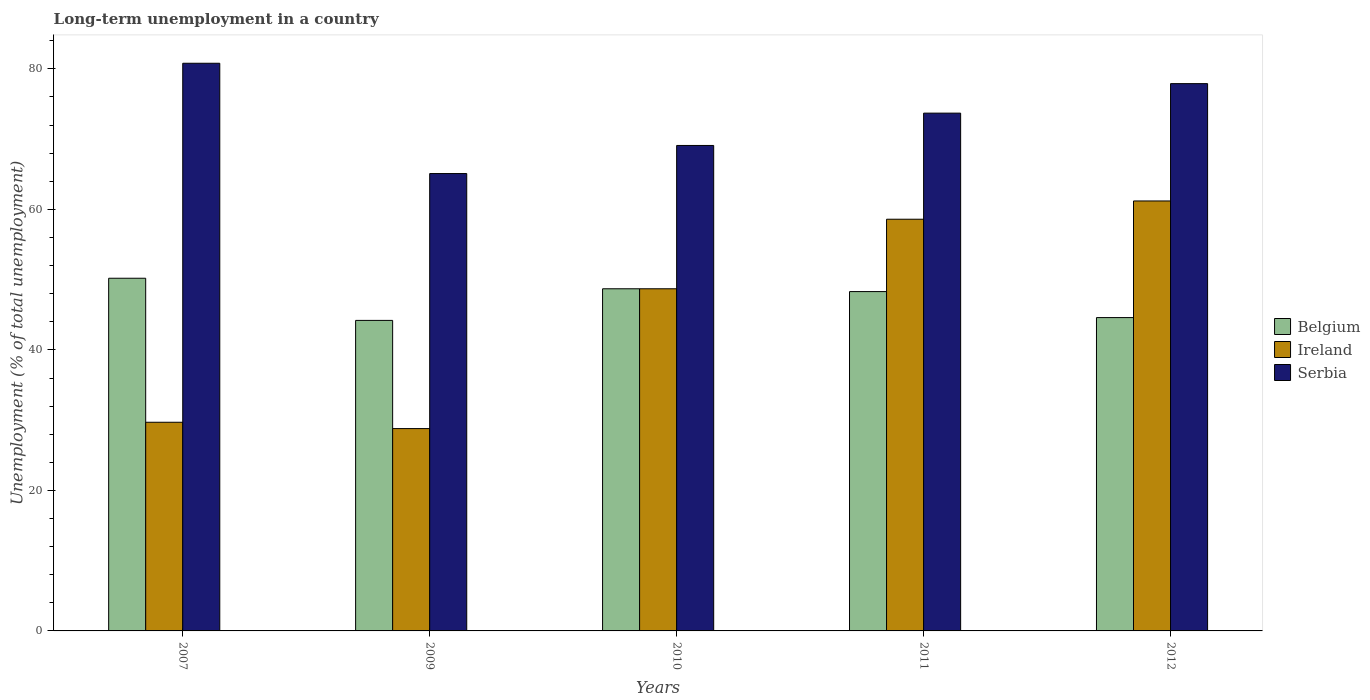How many different coloured bars are there?
Keep it short and to the point. 3. Are the number of bars per tick equal to the number of legend labels?
Offer a very short reply. Yes. Are the number of bars on each tick of the X-axis equal?
Your answer should be very brief. Yes. In how many cases, is the number of bars for a given year not equal to the number of legend labels?
Your answer should be compact. 0. What is the percentage of long-term unemployed population in Serbia in 2007?
Make the answer very short. 80.8. Across all years, what is the maximum percentage of long-term unemployed population in Ireland?
Ensure brevity in your answer.  61.2. Across all years, what is the minimum percentage of long-term unemployed population in Ireland?
Provide a short and direct response. 28.8. In which year was the percentage of long-term unemployed population in Belgium maximum?
Ensure brevity in your answer.  2007. In which year was the percentage of long-term unemployed population in Belgium minimum?
Ensure brevity in your answer.  2009. What is the total percentage of long-term unemployed population in Belgium in the graph?
Keep it short and to the point. 236. What is the difference between the percentage of long-term unemployed population in Serbia in 2007 and that in 2012?
Offer a terse response. 2.9. What is the difference between the percentage of long-term unemployed population in Ireland in 2010 and the percentage of long-term unemployed population in Serbia in 2012?
Ensure brevity in your answer.  -29.2. What is the average percentage of long-term unemployed population in Serbia per year?
Offer a terse response. 73.32. In the year 2007, what is the difference between the percentage of long-term unemployed population in Belgium and percentage of long-term unemployed population in Ireland?
Give a very brief answer. 20.5. What is the ratio of the percentage of long-term unemployed population in Belgium in 2010 to that in 2012?
Offer a very short reply. 1.09. What is the difference between the highest and the second highest percentage of long-term unemployed population in Ireland?
Keep it short and to the point. 2.6. What is the difference between the highest and the lowest percentage of long-term unemployed population in Serbia?
Keep it short and to the point. 15.7. What does the 3rd bar from the left in 2010 represents?
Keep it short and to the point. Serbia. What does the 3rd bar from the right in 2007 represents?
Keep it short and to the point. Belgium. Is it the case that in every year, the sum of the percentage of long-term unemployed population in Ireland and percentage of long-term unemployed population in Serbia is greater than the percentage of long-term unemployed population in Belgium?
Ensure brevity in your answer.  Yes. Are the values on the major ticks of Y-axis written in scientific E-notation?
Offer a very short reply. No. Does the graph contain any zero values?
Keep it short and to the point. No. Does the graph contain grids?
Provide a succinct answer. No. Where does the legend appear in the graph?
Offer a terse response. Center right. How many legend labels are there?
Your answer should be compact. 3. How are the legend labels stacked?
Ensure brevity in your answer.  Vertical. What is the title of the graph?
Provide a succinct answer. Long-term unemployment in a country. Does "French Polynesia" appear as one of the legend labels in the graph?
Provide a short and direct response. No. What is the label or title of the Y-axis?
Your response must be concise. Unemployment (% of total unemployment). What is the Unemployment (% of total unemployment) of Belgium in 2007?
Offer a very short reply. 50.2. What is the Unemployment (% of total unemployment) in Ireland in 2007?
Your answer should be compact. 29.7. What is the Unemployment (% of total unemployment) in Serbia in 2007?
Provide a short and direct response. 80.8. What is the Unemployment (% of total unemployment) in Belgium in 2009?
Offer a terse response. 44.2. What is the Unemployment (% of total unemployment) of Ireland in 2009?
Your answer should be compact. 28.8. What is the Unemployment (% of total unemployment) in Serbia in 2009?
Offer a very short reply. 65.1. What is the Unemployment (% of total unemployment) of Belgium in 2010?
Give a very brief answer. 48.7. What is the Unemployment (% of total unemployment) in Ireland in 2010?
Your answer should be very brief. 48.7. What is the Unemployment (% of total unemployment) of Serbia in 2010?
Ensure brevity in your answer.  69.1. What is the Unemployment (% of total unemployment) in Belgium in 2011?
Make the answer very short. 48.3. What is the Unemployment (% of total unemployment) of Ireland in 2011?
Your answer should be very brief. 58.6. What is the Unemployment (% of total unemployment) of Serbia in 2011?
Your response must be concise. 73.7. What is the Unemployment (% of total unemployment) of Belgium in 2012?
Your response must be concise. 44.6. What is the Unemployment (% of total unemployment) in Ireland in 2012?
Offer a very short reply. 61.2. What is the Unemployment (% of total unemployment) of Serbia in 2012?
Make the answer very short. 77.9. Across all years, what is the maximum Unemployment (% of total unemployment) of Belgium?
Provide a short and direct response. 50.2. Across all years, what is the maximum Unemployment (% of total unemployment) of Ireland?
Offer a terse response. 61.2. Across all years, what is the maximum Unemployment (% of total unemployment) of Serbia?
Keep it short and to the point. 80.8. Across all years, what is the minimum Unemployment (% of total unemployment) of Belgium?
Offer a very short reply. 44.2. Across all years, what is the minimum Unemployment (% of total unemployment) in Ireland?
Provide a succinct answer. 28.8. Across all years, what is the minimum Unemployment (% of total unemployment) in Serbia?
Make the answer very short. 65.1. What is the total Unemployment (% of total unemployment) of Belgium in the graph?
Your answer should be very brief. 236. What is the total Unemployment (% of total unemployment) of Ireland in the graph?
Give a very brief answer. 227. What is the total Unemployment (% of total unemployment) of Serbia in the graph?
Your response must be concise. 366.6. What is the difference between the Unemployment (% of total unemployment) of Belgium in 2007 and that in 2009?
Provide a short and direct response. 6. What is the difference between the Unemployment (% of total unemployment) in Serbia in 2007 and that in 2009?
Ensure brevity in your answer.  15.7. What is the difference between the Unemployment (% of total unemployment) in Ireland in 2007 and that in 2010?
Keep it short and to the point. -19. What is the difference between the Unemployment (% of total unemployment) in Serbia in 2007 and that in 2010?
Your answer should be compact. 11.7. What is the difference between the Unemployment (% of total unemployment) of Belgium in 2007 and that in 2011?
Offer a terse response. 1.9. What is the difference between the Unemployment (% of total unemployment) of Ireland in 2007 and that in 2011?
Your answer should be very brief. -28.9. What is the difference between the Unemployment (% of total unemployment) in Serbia in 2007 and that in 2011?
Provide a short and direct response. 7.1. What is the difference between the Unemployment (% of total unemployment) in Belgium in 2007 and that in 2012?
Provide a succinct answer. 5.6. What is the difference between the Unemployment (% of total unemployment) of Ireland in 2007 and that in 2012?
Your answer should be very brief. -31.5. What is the difference between the Unemployment (% of total unemployment) of Ireland in 2009 and that in 2010?
Ensure brevity in your answer.  -19.9. What is the difference between the Unemployment (% of total unemployment) in Belgium in 2009 and that in 2011?
Make the answer very short. -4.1. What is the difference between the Unemployment (% of total unemployment) of Ireland in 2009 and that in 2011?
Provide a short and direct response. -29.8. What is the difference between the Unemployment (% of total unemployment) in Serbia in 2009 and that in 2011?
Provide a succinct answer. -8.6. What is the difference between the Unemployment (% of total unemployment) of Belgium in 2009 and that in 2012?
Your answer should be very brief. -0.4. What is the difference between the Unemployment (% of total unemployment) of Ireland in 2009 and that in 2012?
Make the answer very short. -32.4. What is the difference between the Unemployment (% of total unemployment) of Serbia in 2009 and that in 2012?
Make the answer very short. -12.8. What is the difference between the Unemployment (% of total unemployment) of Belgium in 2010 and that in 2011?
Provide a short and direct response. 0.4. What is the difference between the Unemployment (% of total unemployment) of Ireland in 2010 and that in 2011?
Your answer should be very brief. -9.9. What is the difference between the Unemployment (% of total unemployment) in Serbia in 2010 and that in 2011?
Your response must be concise. -4.6. What is the difference between the Unemployment (% of total unemployment) of Serbia in 2010 and that in 2012?
Give a very brief answer. -8.8. What is the difference between the Unemployment (% of total unemployment) of Belgium in 2007 and the Unemployment (% of total unemployment) of Ireland in 2009?
Your response must be concise. 21.4. What is the difference between the Unemployment (% of total unemployment) of Belgium in 2007 and the Unemployment (% of total unemployment) of Serbia in 2009?
Your response must be concise. -14.9. What is the difference between the Unemployment (% of total unemployment) in Ireland in 2007 and the Unemployment (% of total unemployment) in Serbia in 2009?
Give a very brief answer. -35.4. What is the difference between the Unemployment (% of total unemployment) in Belgium in 2007 and the Unemployment (% of total unemployment) in Ireland in 2010?
Provide a short and direct response. 1.5. What is the difference between the Unemployment (% of total unemployment) in Belgium in 2007 and the Unemployment (% of total unemployment) in Serbia in 2010?
Give a very brief answer. -18.9. What is the difference between the Unemployment (% of total unemployment) in Ireland in 2007 and the Unemployment (% of total unemployment) in Serbia in 2010?
Your answer should be compact. -39.4. What is the difference between the Unemployment (% of total unemployment) of Belgium in 2007 and the Unemployment (% of total unemployment) of Ireland in 2011?
Offer a terse response. -8.4. What is the difference between the Unemployment (% of total unemployment) of Belgium in 2007 and the Unemployment (% of total unemployment) of Serbia in 2011?
Ensure brevity in your answer.  -23.5. What is the difference between the Unemployment (% of total unemployment) in Ireland in 2007 and the Unemployment (% of total unemployment) in Serbia in 2011?
Make the answer very short. -44. What is the difference between the Unemployment (% of total unemployment) in Belgium in 2007 and the Unemployment (% of total unemployment) in Ireland in 2012?
Provide a succinct answer. -11. What is the difference between the Unemployment (% of total unemployment) of Belgium in 2007 and the Unemployment (% of total unemployment) of Serbia in 2012?
Keep it short and to the point. -27.7. What is the difference between the Unemployment (% of total unemployment) of Ireland in 2007 and the Unemployment (% of total unemployment) of Serbia in 2012?
Provide a succinct answer. -48.2. What is the difference between the Unemployment (% of total unemployment) of Belgium in 2009 and the Unemployment (% of total unemployment) of Serbia in 2010?
Keep it short and to the point. -24.9. What is the difference between the Unemployment (% of total unemployment) in Ireland in 2009 and the Unemployment (% of total unemployment) in Serbia in 2010?
Offer a very short reply. -40.3. What is the difference between the Unemployment (% of total unemployment) of Belgium in 2009 and the Unemployment (% of total unemployment) of Ireland in 2011?
Offer a very short reply. -14.4. What is the difference between the Unemployment (% of total unemployment) in Belgium in 2009 and the Unemployment (% of total unemployment) in Serbia in 2011?
Your answer should be compact. -29.5. What is the difference between the Unemployment (% of total unemployment) of Ireland in 2009 and the Unemployment (% of total unemployment) of Serbia in 2011?
Your answer should be compact. -44.9. What is the difference between the Unemployment (% of total unemployment) of Belgium in 2009 and the Unemployment (% of total unemployment) of Ireland in 2012?
Provide a short and direct response. -17. What is the difference between the Unemployment (% of total unemployment) of Belgium in 2009 and the Unemployment (% of total unemployment) of Serbia in 2012?
Offer a very short reply. -33.7. What is the difference between the Unemployment (% of total unemployment) of Ireland in 2009 and the Unemployment (% of total unemployment) of Serbia in 2012?
Provide a short and direct response. -49.1. What is the difference between the Unemployment (% of total unemployment) in Ireland in 2010 and the Unemployment (% of total unemployment) in Serbia in 2011?
Your answer should be compact. -25. What is the difference between the Unemployment (% of total unemployment) in Belgium in 2010 and the Unemployment (% of total unemployment) in Serbia in 2012?
Your response must be concise. -29.2. What is the difference between the Unemployment (% of total unemployment) of Ireland in 2010 and the Unemployment (% of total unemployment) of Serbia in 2012?
Make the answer very short. -29.2. What is the difference between the Unemployment (% of total unemployment) in Belgium in 2011 and the Unemployment (% of total unemployment) in Serbia in 2012?
Ensure brevity in your answer.  -29.6. What is the difference between the Unemployment (% of total unemployment) in Ireland in 2011 and the Unemployment (% of total unemployment) in Serbia in 2012?
Give a very brief answer. -19.3. What is the average Unemployment (% of total unemployment) of Belgium per year?
Keep it short and to the point. 47.2. What is the average Unemployment (% of total unemployment) in Ireland per year?
Your answer should be very brief. 45.4. What is the average Unemployment (% of total unemployment) in Serbia per year?
Give a very brief answer. 73.32. In the year 2007, what is the difference between the Unemployment (% of total unemployment) in Belgium and Unemployment (% of total unemployment) in Serbia?
Give a very brief answer. -30.6. In the year 2007, what is the difference between the Unemployment (% of total unemployment) of Ireland and Unemployment (% of total unemployment) of Serbia?
Offer a very short reply. -51.1. In the year 2009, what is the difference between the Unemployment (% of total unemployment) in Belgium and Unemployment (% of total unemployment) in Ireland?
Your answer should be very brief. 15.4. In the year 2009, what is the difference between the Unemployment (% of total unemployment) in Belgium and Unemployment (% of total unemployment) in Serbia?
Offer a terse response. -20.9. In the year 2009, what is the difference between the Unemployment (% of total unemployment) in Ireland and Unemployment (% of total unemployment) in Serbia?
Offer a terse response. -36.3. In the year 2010, what is the difference between the Unemployment (% of total unemployment) of Belgium and Unemployment (% of total unemployment) of Ireland?
Keep it short and to the point. 0. In the year 2010, what is the difference between the Unemployment (% of total unemployment) of Belgium and Unemployment (% of total unemployment) of Serbia?
Give a very brief answer. -20.4. In the year 2010, what is the difference between the Unemployment (% of total unemployment) in Ireland and Unemployment (% of total unemployment) in Serbia?
Your answer should be compact. -20.4. In the year 2011, what is the difference between the Unemployment (% of total unemployment) of Belgium and Unemployment (% of total unemployment) of Ireland?
Give a very brief answer. -10.3. In the year 2011, what is the difference between the Unemployment (% of total unemployment) in Belgium and Unemployment (% of total unemployment) in Serbia?
Make the answer very short. -25.4. In the year 2011, what is the difference between the Unemployment (% of total unemployment) of Ireland and Unemployment (% of total unemployment) of Serbia?
Offer a very short reply. -15.1. In the year 2012, what is the difference between the Unemployment (% of total unemployment) of Belgium and Unemployment (% of total unemployment) of Ireland?
Keep it short and to the point. -16.6. In the year 2012, what is the difference between the Unemployment (% of total unemployment) in Belgium and Unemployment (% of total unemployment) in Serbia?
Give a very brief answer. -33.3. In the year 2012, what is the difference between the Unemployment (% of total unemployment) in Ireland and Unemployment (% of total unemployment) in Serbia?
Ensure brevity in your answer.  -16.7. What is the ratio of the Unemployment (% of total unemployment) of Belgium in 2007 to that in 2009?
Offer a very short reply. 1.14. What is the ratio of the Unemployment (% of total unemployment) in Ireland in 2007 to that in 2009?
Provide a short and direct response. 1.03. What is the ratio of the Unemployment (% of total unemployment) in Serbia in 2007 to that in 2009?
Ensure brevity in your answer.  1.24. What is the ratio of the Unemployment (% of total unemployment) in Belgium in 2007 to that in 2010?
Your answer should be very brief. 1.03. What is the ratio of the Unemployment (% of total unemployment) of Ireland in 2007 to that in 2010?
Offer a very short reply. 0.61. What is the ratio of the Unemployment (% of total unemployment) in Serbia in 2007 to that in 2010?
Offer a terse response. 1.17. What is the ratio of the Unemployment (% of total unemployment) in Belgium in 2007 to that in 2011?
Give a very brief answer. 1.04. What is the ratio of the Unemployment (% of total unemployment) in Ireland in 2007 to that in 2011?
Ensure brevity in your answer.  0.51. What is the ratio of the Unemployment (% of total unemployment) in Serbia in 2007 to that in 2011?
Provide a short and direct response. 1.1. What is the ratio of the Unemployment (% of total unemployment) in Belgium in 2007 to that in 2012?
Give a very brief answer. 1.13. What is the ratio of the Unemployment (% of total unemployment) in Ireland in 2007 to that in 2012?
Offer a very short reply. 0.49. What is the ratio of the Unemployment (% of total unemployment) of Serbia in 2007 to that in 2012?
Your answer should be very brief. 1.04. What is the ratio of the Unemployment (% of total unemployment) in Belgium in 2009 to that in 2010?
Your answer should be very brief. 0.91. What is the ratio of the Unemployment (% of total unemployment) in Ireland in 2009 to that in 2010?
Keep it short and to the point. 0.59. What is the ratio of the Unemployment (% of total unemployment) in Serbia in 2009 to that in 2010?
Provide a succinct answer. 0.94. What is the ratio of the Unemployment (% of total unemployment) in Belgium in 2009 to that in 2011?
Give a very brief answer. 0.92. What is the ratio of the Unemployment (% of total unemployment) of Ireland in 2009 to that in 2011?
Provide a short and direct response. 0.49. What is the ratio of the Unemployment (% of total unemployment) of Serbia in 2009 to that in 2011?
Offer a very short reply. 0.88. What is the ratio of the Unemployment (% of total unemployment) of Ireland in 2009 to that in 2012?
Provide a short and direct response. 0.47. What is the ratio of the Unemployment (% of total unemployment) of Serbia in 2009 to that in 2012?
Your answer should be compact. 0.84. What is the ratio of the Unemployment (% of total unemployment) in Belgium in 2010 to that in 2011?
Keep it short and to the point. 1.01. What is the ratio of the Unemployment (% of total unemployment) of Ireland in 2010 to that in 2011?
Provide a succinct answer. 0.83. What is the ratio of the Unemployment (% of total unemployment) of Serbia in 2010 to that in 2011?
Your answer should be very brief. 0.94. What is the ratio of the Unemployment (% of total unemployment) in Belgium in 2010 to that in 2012?
Provide a short and direct response. 1.09. What is the ratio of the Unemployment (% of total unemployment) of Ireland in 2010 to that in 2012?
Your response must be concise. 0.8. What is the ratio of the Unemployment (% of total unemployment) of Serbia in 2010 to that in 2012?
Your response must be concise. 0.89. What is the ratio of the Unemployment (% of total unemployment) of Belgium in 2011 to that in 2012?
Your response must be concise. 1.08. What is the ratio of the Unemployment (% of total unemployment) in Ireland in 2011 to that in 2012?
Offer a terse response. 0.96. What is the ratio of the Unemployment (% of total unemployment) of Serbia in 2011 to that in 2012?
Keep it short and to the point. 0.95. What is the difference between the highest and the second highest Unemployment (% of total unemployment) of Ireland?
Provide a short and direct response. 2.6. What is the difference between the highest and the lowest Unemployment (% of total unemployment) in Ireland?
Give a very brief answer. 32.4. 